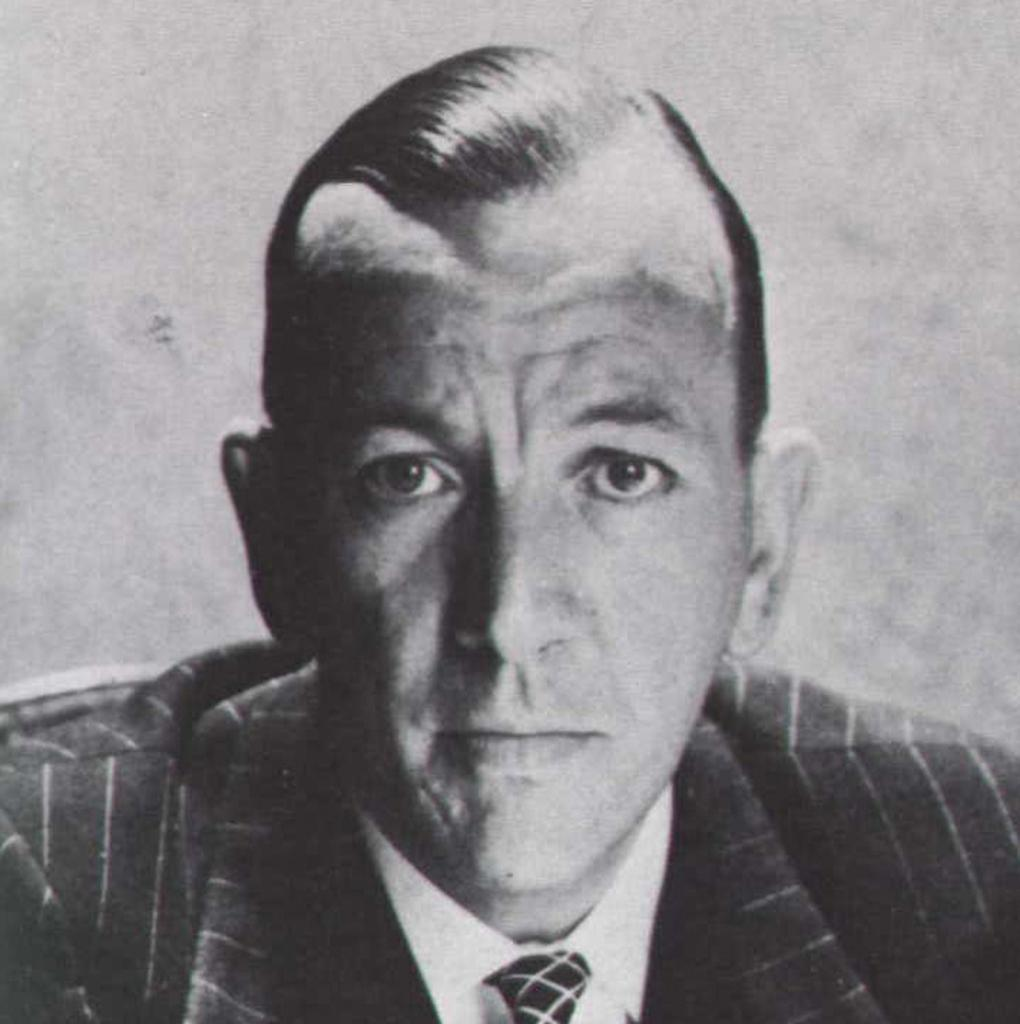What is the color scheme of the image? The image is black and white. Can you describe the person in the image? There is a man in the image. What type of clothing is the man wearing? The man is wearing a blazer. How many train tracks can be seen in the image? There are no train tracks present in the image. What type of balls is the man holding in the image? There are no balls visible in the image; the man is wearing a blazer. 